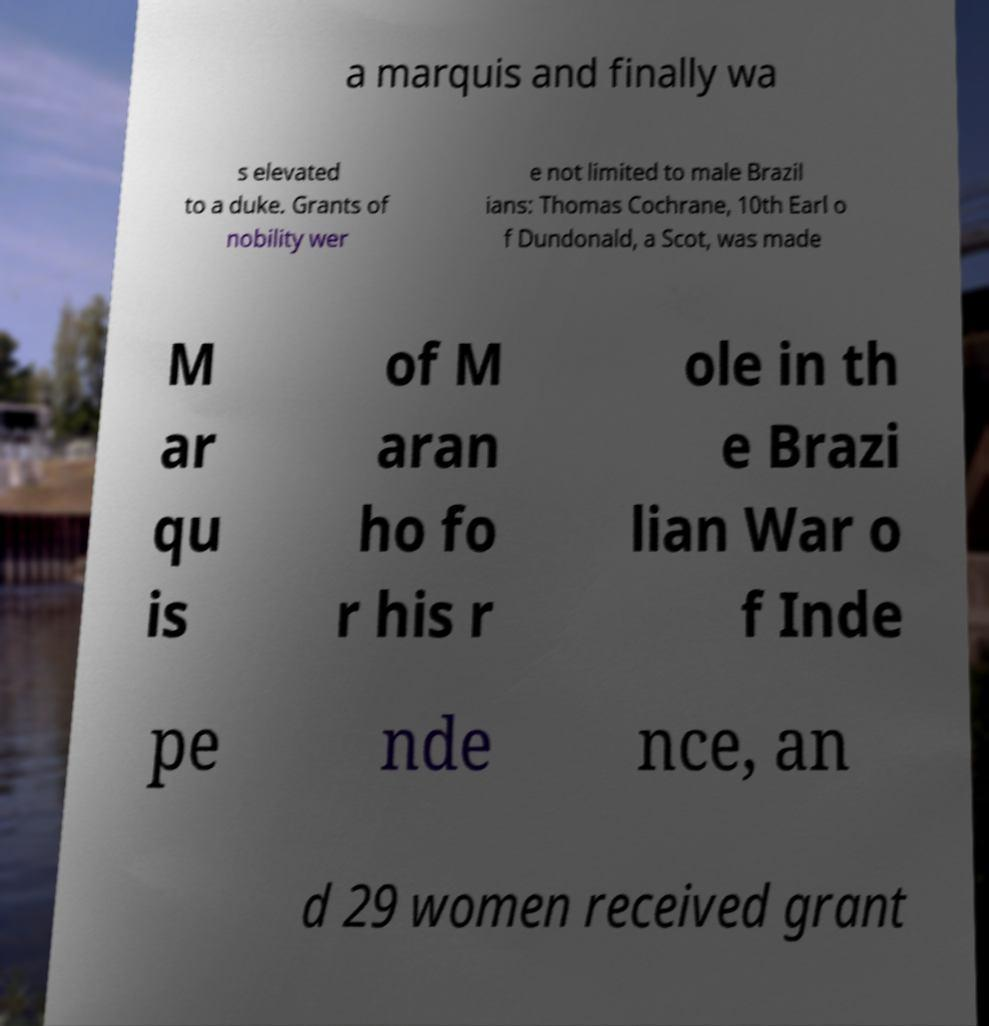Could you extract and type out the text from this image? a marquis and finally wa s elevated to a duke. Grants of nobility wer e not limited to male Brazil ians: Thomas Cochrane, 10th Earl o f Dundonald, a Scot, was made M ar qu is of M aran ho fo r his r ole in th e Brazi lian War o f Inde pe nde nce, an d 29 women received grant 